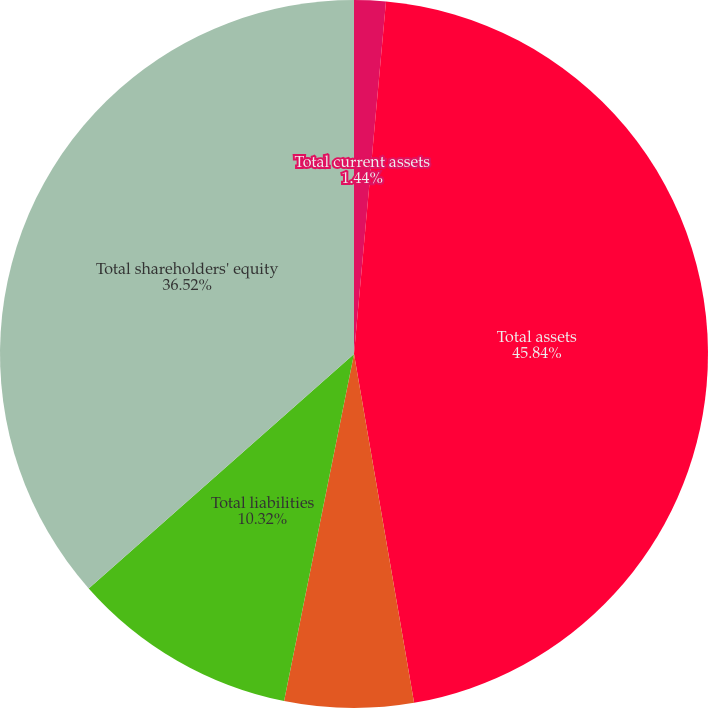<chart> <loc_0><loc_0><loc_500><loc_500><pie_chart><fcel>Total current assets<fcel>Total assets<fcel>Total current liabilities<fcel>Total liabilities<fcel>Total shareholders' equity<nl><fcel>1.44%<fcel>45.85%<fcel>5.88%<fcel>10.32%<fcel>36.52%<nl></chart> 